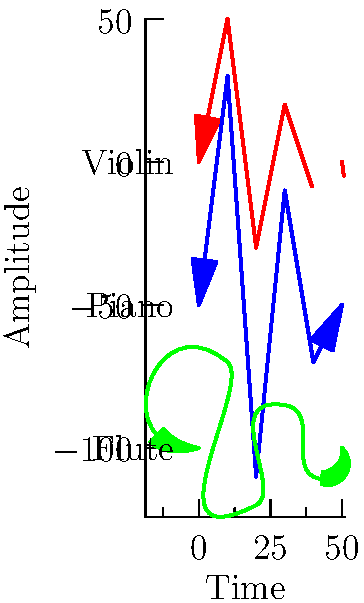As a pianist familiar with various classical instruments, analyze the waveforms shown in the graph. Which instrument's waveform exhibits the most abrupt changes in amplitude, indicating a percussive quality? To answer this question, we need to examine the characteristics of each waveform:

1. Violin (red waveform):
   - Shows smooth transitions between peaks and troughs
   - Has a relatively consistent amplitude range

2. Piano (blue waveform):
   - Displays sharp, angular changes in amplitude
   - Has the largest amplitude range among the three instruments
   - Shows a rapid initial attack followed by a gradual decay

3. Flute (green waveform):
   - Exhibits the smoothest, most sinusoidal shape
   - Has the smallest amplitude range
   - Shows gradual transitions between peaks and troughs

The most abrupt changes in amplitude, indicating a percussive quality, are seen in the piano waveform. This is due to the nature of the piano's sound production mechanism, where hammers strike strings, creating an initial sharp attack followed by a decay.

The violin and flute waveforms, in contrast, show smoother transitions, reflecting their sustained sound production methods (bowing and blowing, respectively).
Answer: Piano 